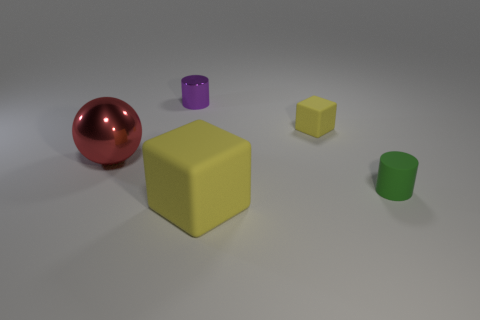Add 3 yellow objects. How many objects exist? 8 Subtract all spheres. How many objects are left? 4 Add 5 red spheres. How many red spheres exist? 6 Subtract 0 purple cubes. How many objects are left? 5 Subtract all cylinders. Subtract all shiny cylinders. How many objects are left? 2 Add 5 large yellow cubes. How many large yellow cubes are left? 6 